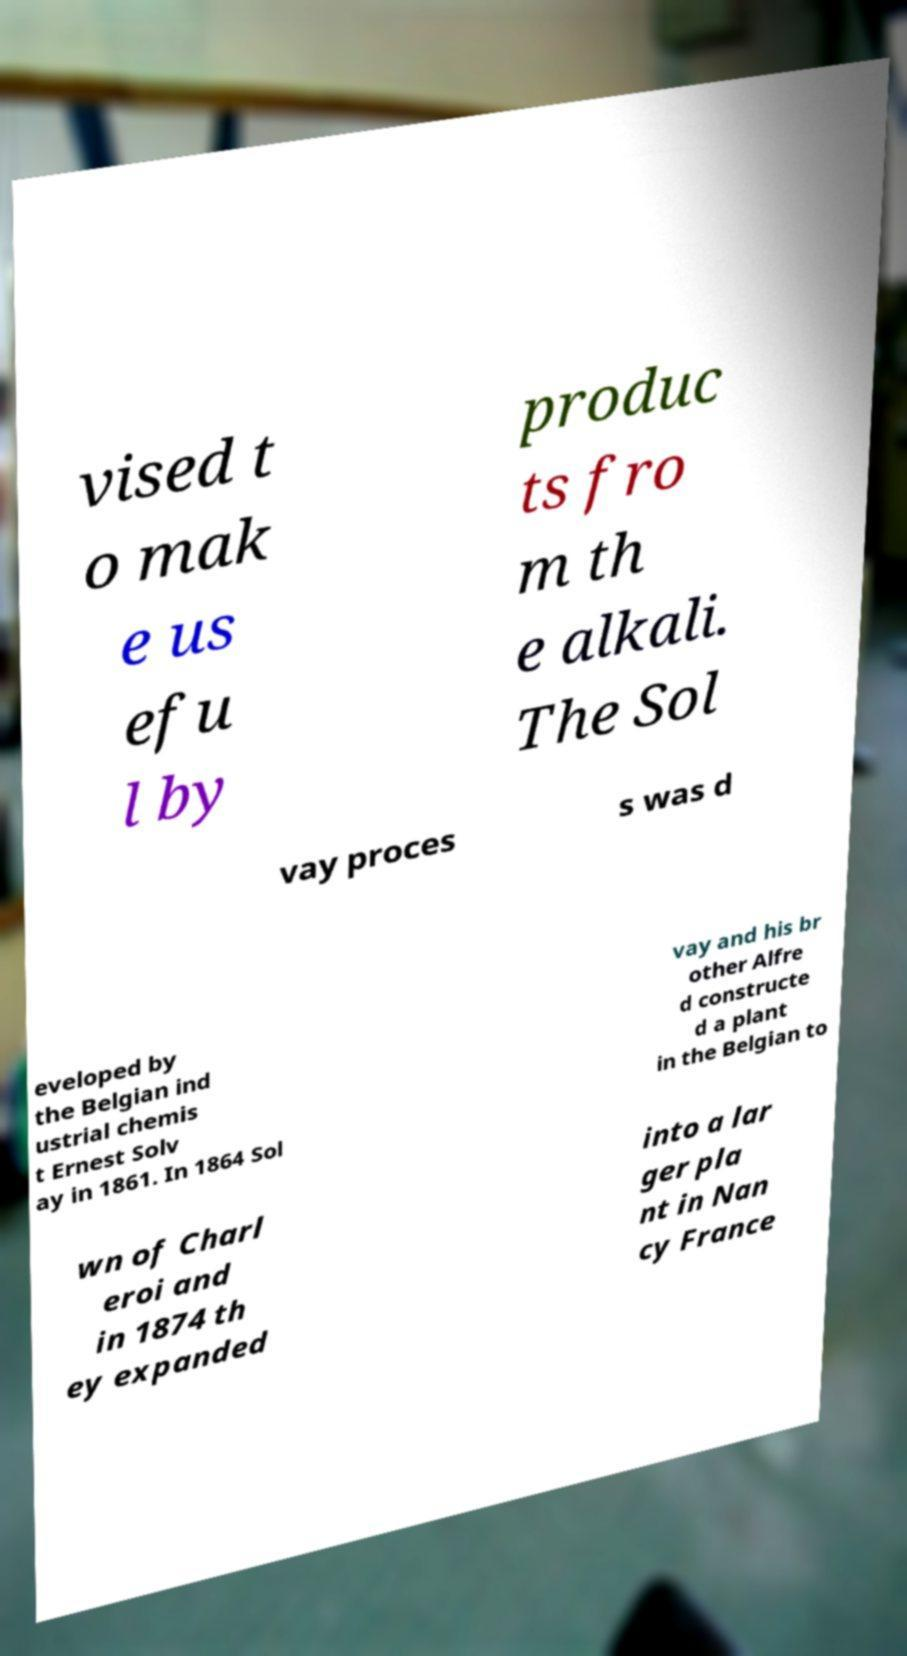There's text embedded in this image that I need extracted. Can you transcribe it verbatim? vised t o mak e us efu l by produc ts fro m th e alkali. The Sol vay proces s was d eveloped by the Belgian ind ustrial chemis t Ernest Solv ay in 1861. In 1864 Sol vay and his br other Alfre d constructe d a plant in the Belgian to wn of Charl eroi and in 1874 th ey expanded into a lar ger pla nt in Nan cy France 